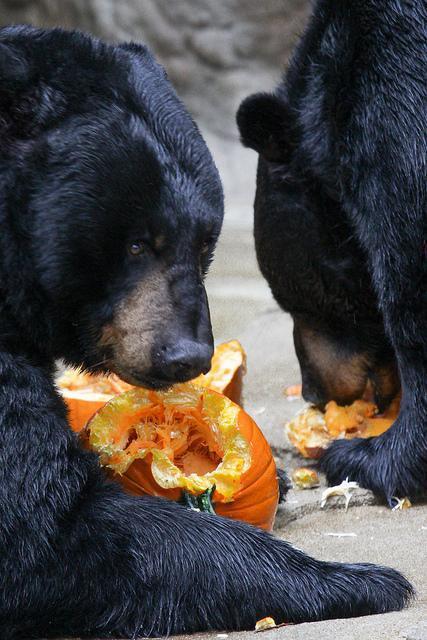How many adult bears are in the picture?
Give a very brief answer. 2. How many bears are there?
Give a very brief answer. 2. How many people in the boat?
Give a very brief answer. 0. 